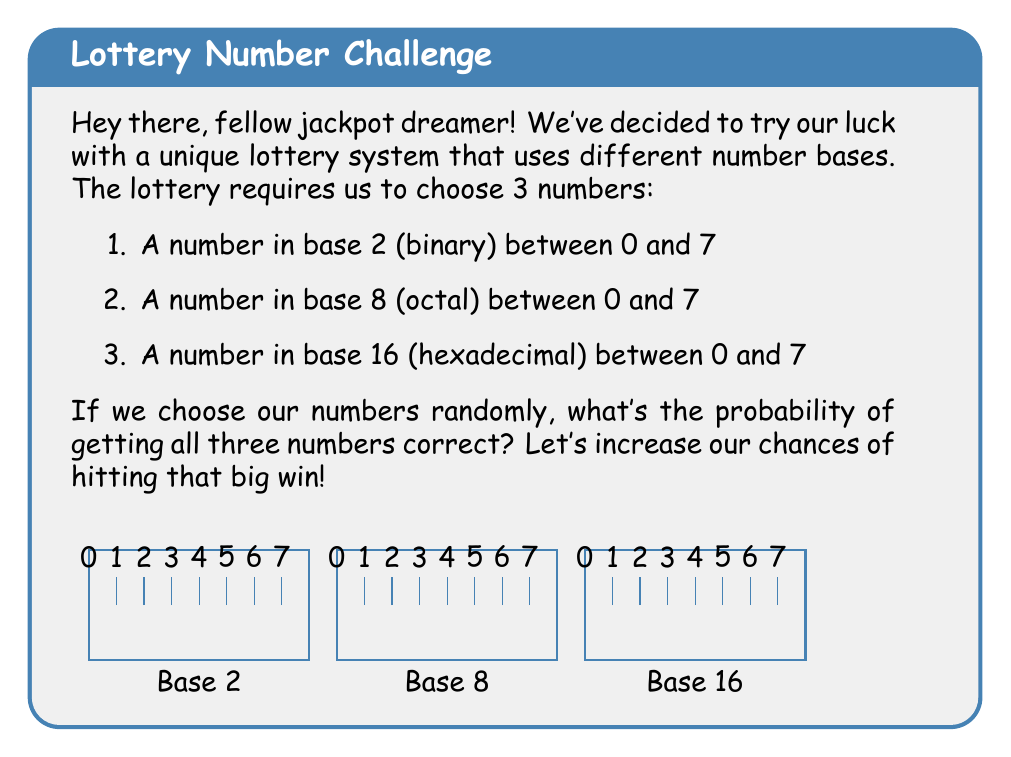Teach me how to tackle this problem. Let's break this down step-by-step:

1) For the binary number (base 2):
   - We have 8 choices (0 to 7 in binary)
   - The probability of choosing the correct number is $\frac{1}{8}$

2) For the octal number (base 8):
   - We also have 8 choices (0 to 7 in octal)
   - The probability of choosing the correct number is $\frac{1}{8}$

3) For the hexadecimal number (base 16):
   - Again, we have 8 choices (0 to 7 in hexadecimal)
   - The probability of choosing the correct number is $\frac{1}{8}$

4) To get all three numbers correct, we need to succeed in all three independent events. In probability theory, we multiply the individual probabilities for independent events.

5) Therefore, the probability of getting all three numbers correct is:

   $$P(\text{all correct}) = \frac{1}{8} \times \frac{1}{8} \times \frac{1}{8} = \frac{1}{512}$$

6) We can simplify this further:
   $$\frac{1}{512} = \frac{1}{8^3} = \frac{1}{2^9}$$

So, the probability of hitting our jackpot with this unique lottery system is $\frac{1}{512}$ or $\frac{1}{2^9}$.
Answer: $\frac{1}{512}$ or $\frac{1}{2^9}$ 